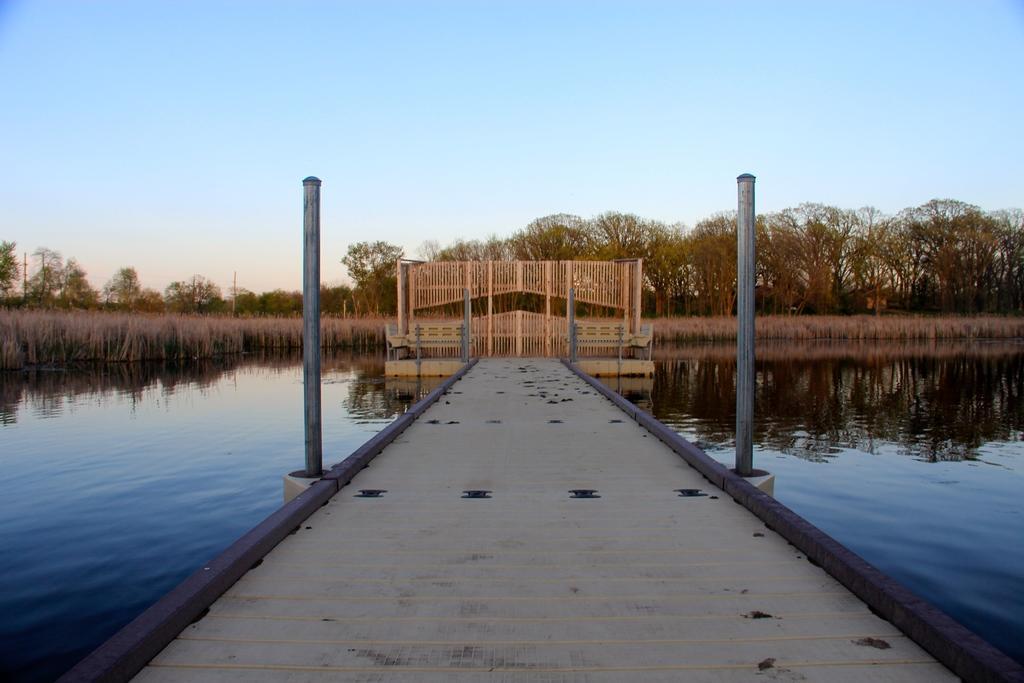Please provide a concise description of this image. In this image in the center there is a bridge and there are poles. In the background there are trees and there is a fence and there is water on both the sides of the bridge. 